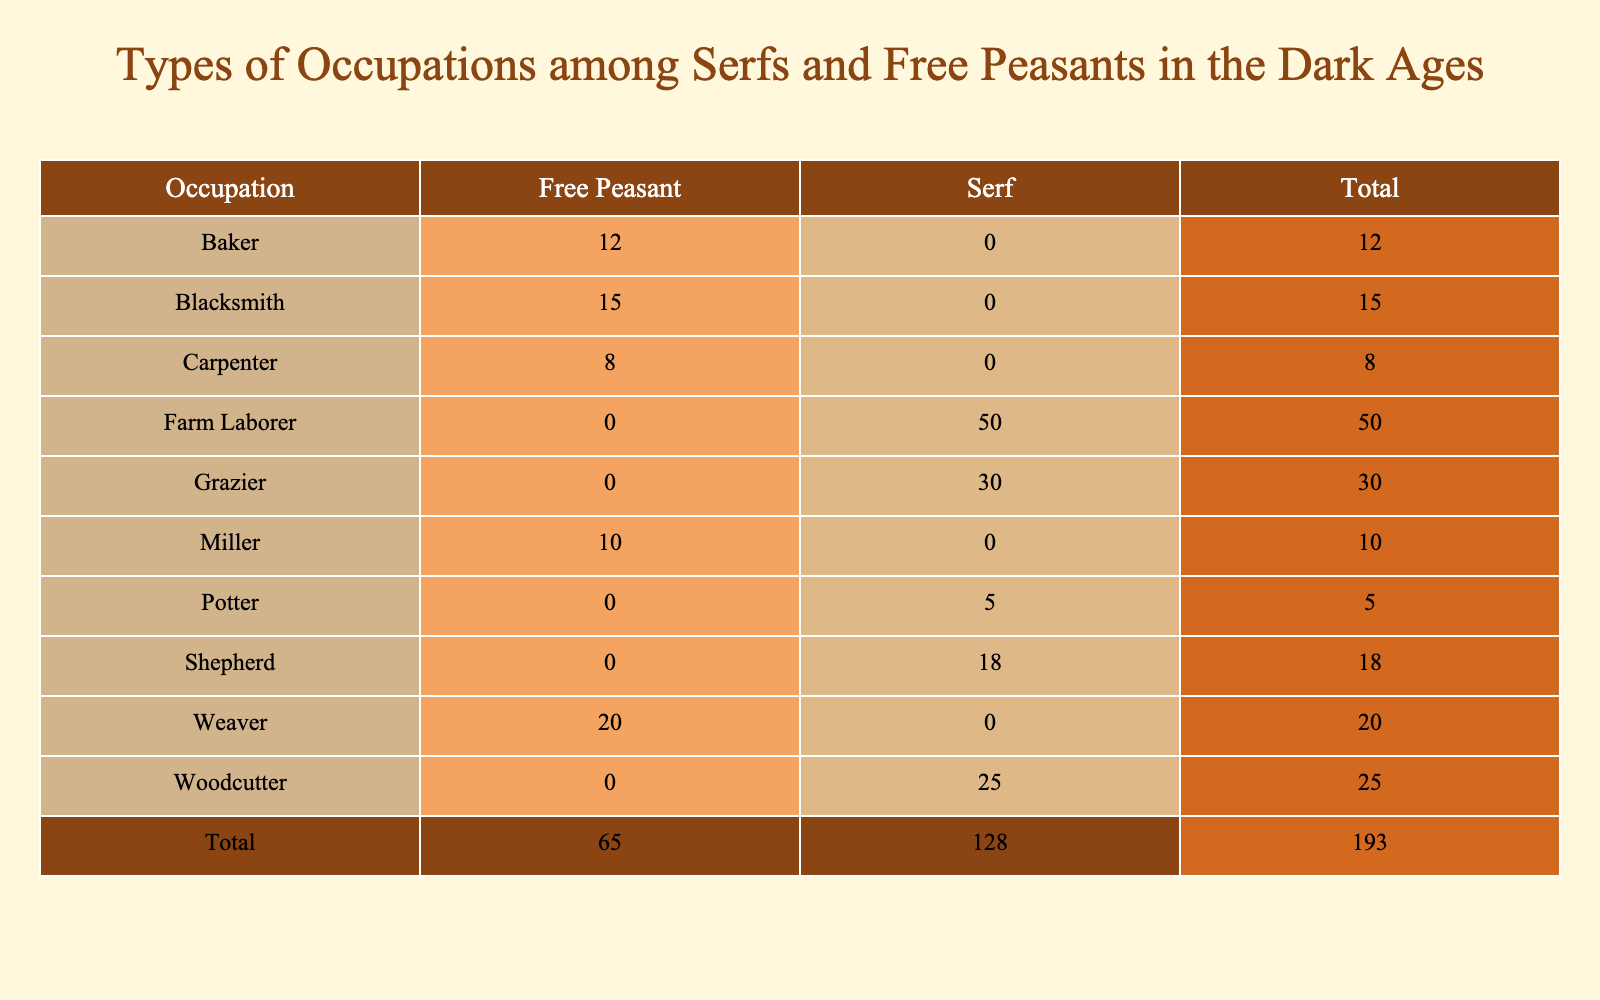What is the total number of free peasants in the table? The table lists the occupations and their respective counts for both serfs and free peasants. To find the total number of free peasants, I will sum the counts associated with free peasants: 15 (Blacksmith) + 10 (Miller) + 12 (Baker) + 20 (Weaver) + 8 (Carpenter) = 75.
Answer: 75 How many more farm laborers are there than potters? According to the table, there are 50 farm laborers and 5 potters. To find the difference, I subtract the count of potters from the count of farm laborers: 50 - 5 = 45.
Answer: 45 Is there a greater number of serfs or free peasants? To answer this, I compare the total counts of serfs and free peasants. The total for serfs: 50 (Farm Laborer) + 30 (Grazier) + 25 (Woodcutter) + 18 (Shepherd) + 5 (Potter) = 128. The total for free peasants: 15 (Blacksmith) + 10 (Miller) + 12 (Baker) + 20 (Weaver) + 8 (Carpenter) = 75. Since 128 > 75, the statement is true.
Answer: Yes What percentage of the total occupations are represented by serfs? First, I calculate the total number of individuals across all occupations: 50 (Farm Laborer) + 15 (Blacksmith) + 10 (Miller) + 30 (Grazier) + 12 (Baker) + 25 (Woodcutter) + 20 (Weaver) + 18 (Shepherd) + 8 (Carpenter) + 5 (Potter) =  273. Next, I find the count of serfs which is 128. To calculate the percentage of the total that are serfs, I use the formula (Number of Serfs / Total Number of Individuals) * 100, resulting in (128 / 273) * 100 ≈ 46.9%.
Answer: 46.9% Which occupation has the least number of individuals, and how many are they? Reviewing the table, I find the lowest count in the Potter occupation, which is 5. I can see that no other occupation has a count lower than this.
Answer: Potter, 5 